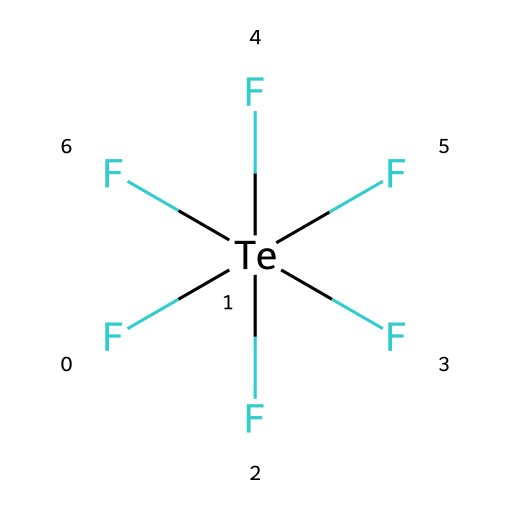How many total fluorine atoms are present in the molecule? The SMILES notation indicates that there are six fluorine atoms directly attached to the tellurium atom, as denoted by the six F's surrounding the Te.
Answer: six What is the central atom in this hypervalent compound? The structure shows that tellurium (Te) is at the center with multiple fluorine atoms bonded to it, which makes it the central atom.
Answer: tellurium How many total bonds are there in tellurium hexafluoride? From the structure, there are six F-Te bonds, meaning the total number of bonds in the compound is six.
Answer: six Is tellurium hexafluoride a polar or nonpolar molecule? With all six fluorine atoms symmetrically bonded to the tellurium, the molecule has an equal distribution of charge, thus making it nonpolar.
Answer: nonpolar What is the coordination number of tellurium in this compound? The coordination number refers to the number of atoms directly bonded to the central atom. In this case, tellurium is bonded to six fluorine atoms, giving it a coordination number of six.
Answer: six What type of hybridization does the tellurium atom in tellurium hexafluoride exhibit? The tellurium atom in this hypervalent compound utilizes sp³d² hybridization to accommodate six bonding pairs with the fluorine atoms.
Answer: sp³d² What category of chemical compound does tellurium hexafluoride belong to? Tellurium hexafluoride is categorized as a hypervalent compound because the tellurium atom expands its valence shell to accommodate more than eight electrons.
Answer: hypervalent compound 